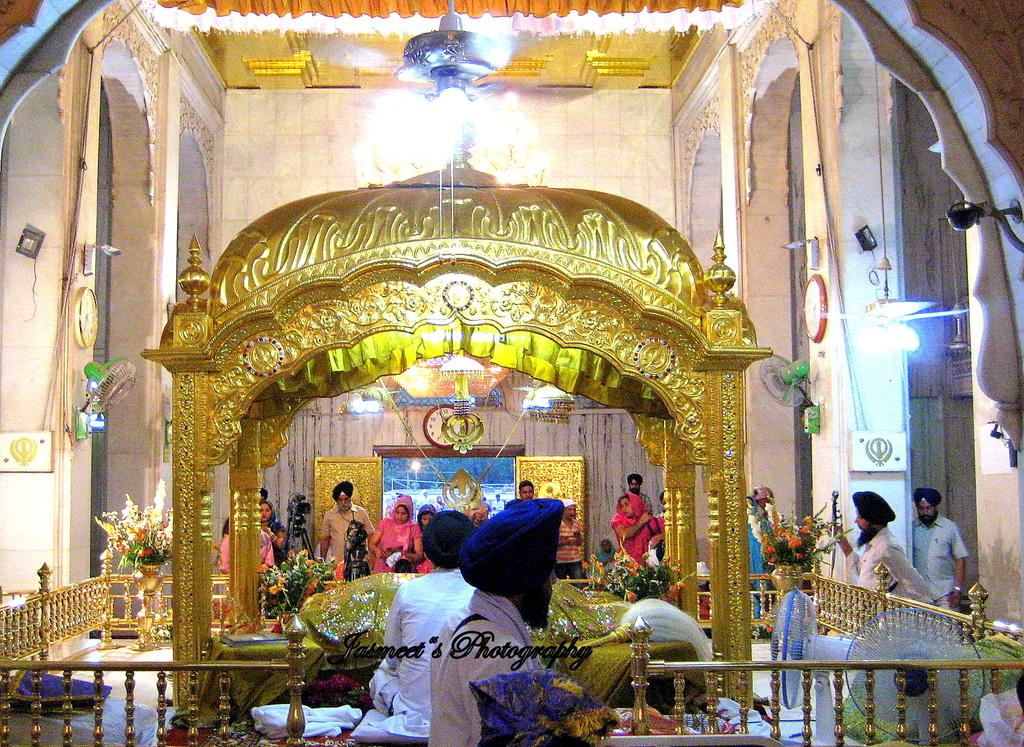Who or what can be seen in the image? There are people in the image. Can you describe the position of the people in the image? The people are standing in the center of the image. What type of structure is visible in the image? There is a temple in the image. What is the purpose of the boundary at the bottom side of the image? The boundary at the bottom side of the image serves to frame or contain the image. What type of meal is being prepared in the temple in the image? There is no indication of a meal being prepared in the temple in the image. 